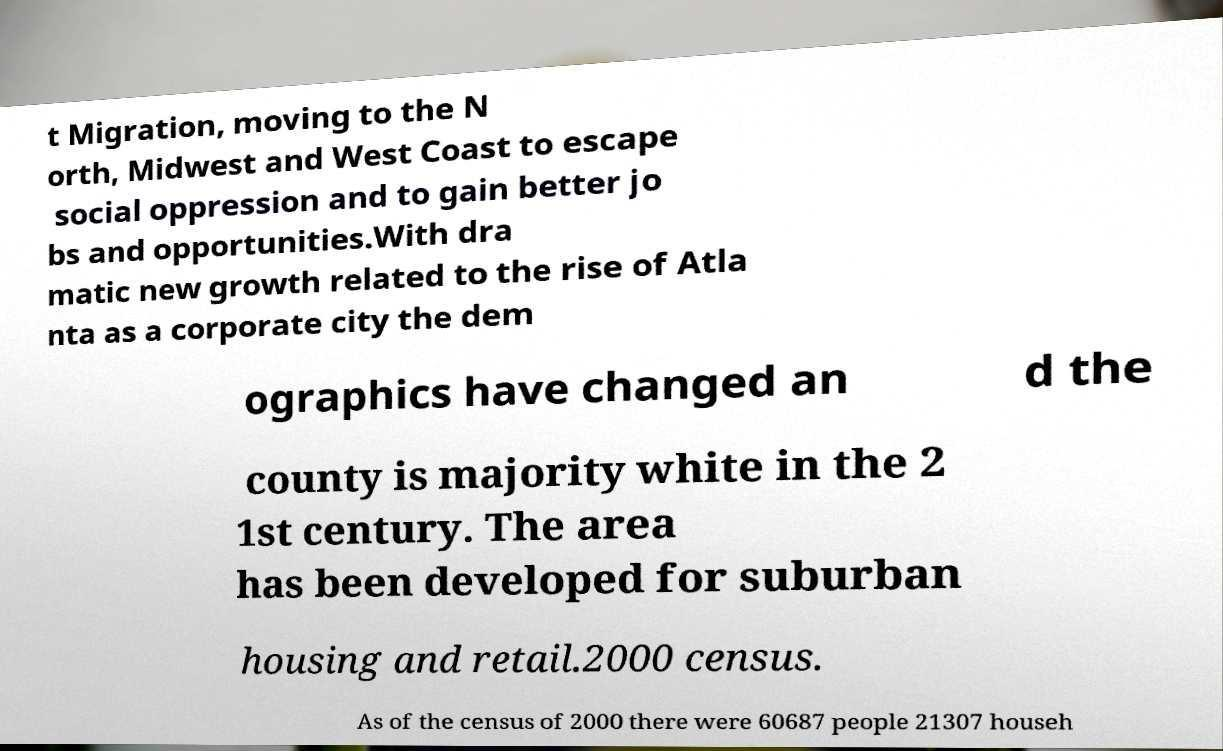Can you accurately transcribe the text from the provided image for me? t Migration, moving to the N orth, Midwest and West Coast to escape social oppression and to gain better jo bs and opportunities.With dra matic new growth related to the rise of Atla nta as a corporate city the dem ographics have changed an d the county is majority white in the 2 1st century. The area has been developed for suburban housing and retail.2000 census. As of the census of 2000 there were 60687 people 21307 househ 